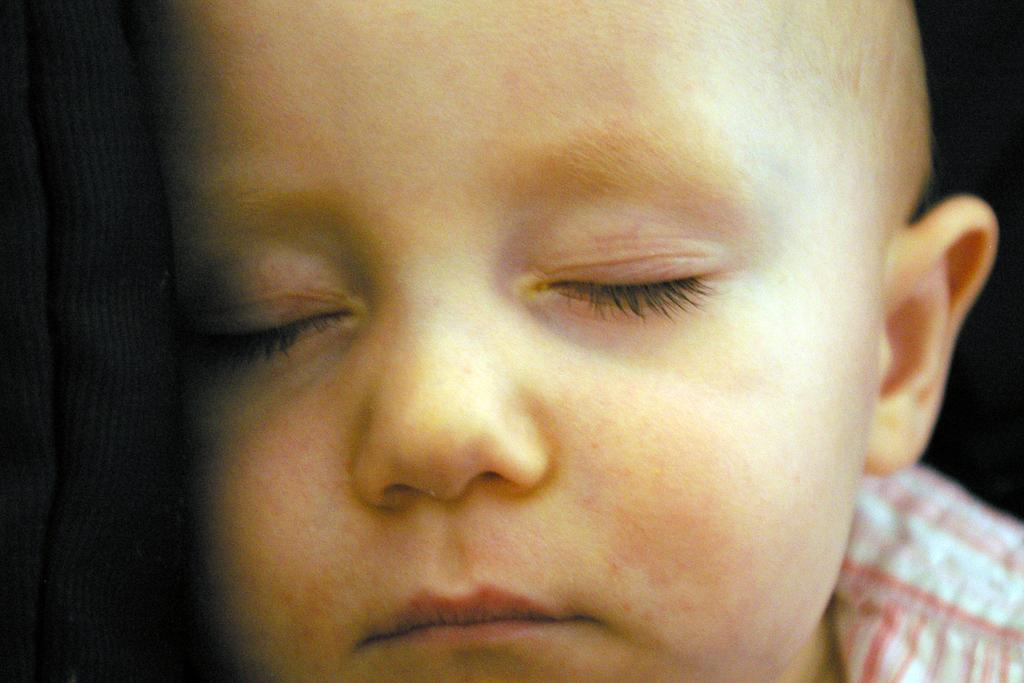What is the main subject of the image? The main subject of the image is a small kid sleeping. Can you describe the object on the left side of the image? There is a black color object on the left side of the image. What type of leaf can be seen on the window in the image? There is no window or leaf present in the image. 